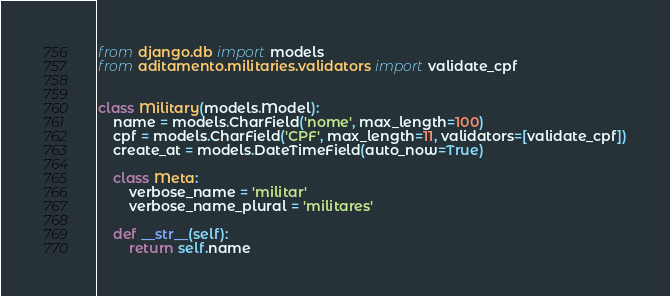<code> <loc_0><loc_0><loc_500><loc_500><_Python_>from django.db import models
from aditamento.militaries.validators import validate_cpf


class Military(models.Model):
    name = models.CharField('nome', max_length=100)
    cpf = models.CharField('CPF', max_length=11, validators=[validate_cpf])
    create_at = models.DateTimeField(auto_now=True)

    class Meta:
        verbose_name = 'militar'
        verbose_name_plural = 'militares'

    def __str__(self):
        return self.name</code> 